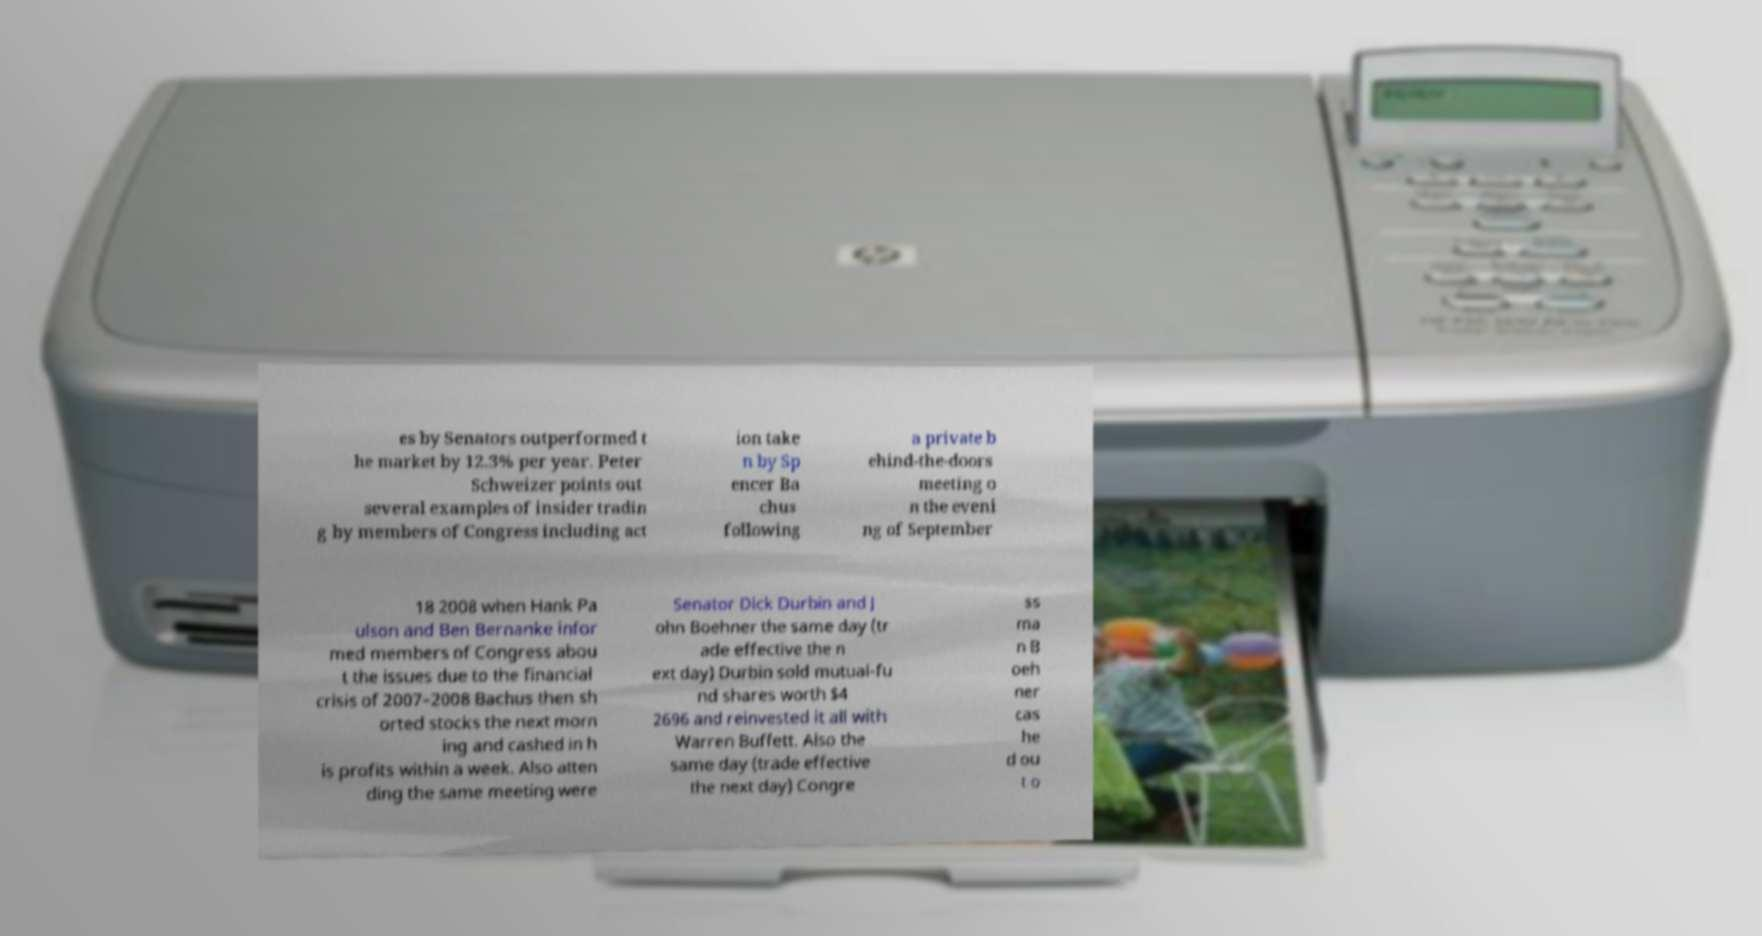Can you read and provide the text displayed in the image?This photo seems to have some interesting text. Can you extract and type it out for me? es by Senators outperformed t he market by 12.3% per year. Peter Schweizer points out several examples of insider tradin g by members of Congress including act ion take n by Sp encer Ba chus following a private b ehind-the-doors meeting o n the eveni ng of September 18 2008 when Hank Pa ulson and Ben Bernanke infor med members of Congress abou t the issues due to the financial crisis of 2007–2008 Bachus then sh orted stocks the next morn ing and cashed in h is profits within a week. Also atten ding the same meeting were Senator Dick Durbin and J ohn Boehner the same day (tr ade effective the n ext day) Durbin sold mutual-fu nd shares worth $4 2696 and reinvested it all with Warren Buffett. Also the same day (trade effective the next day) Congre ss ma n B oeh ner cas he d ou t o 